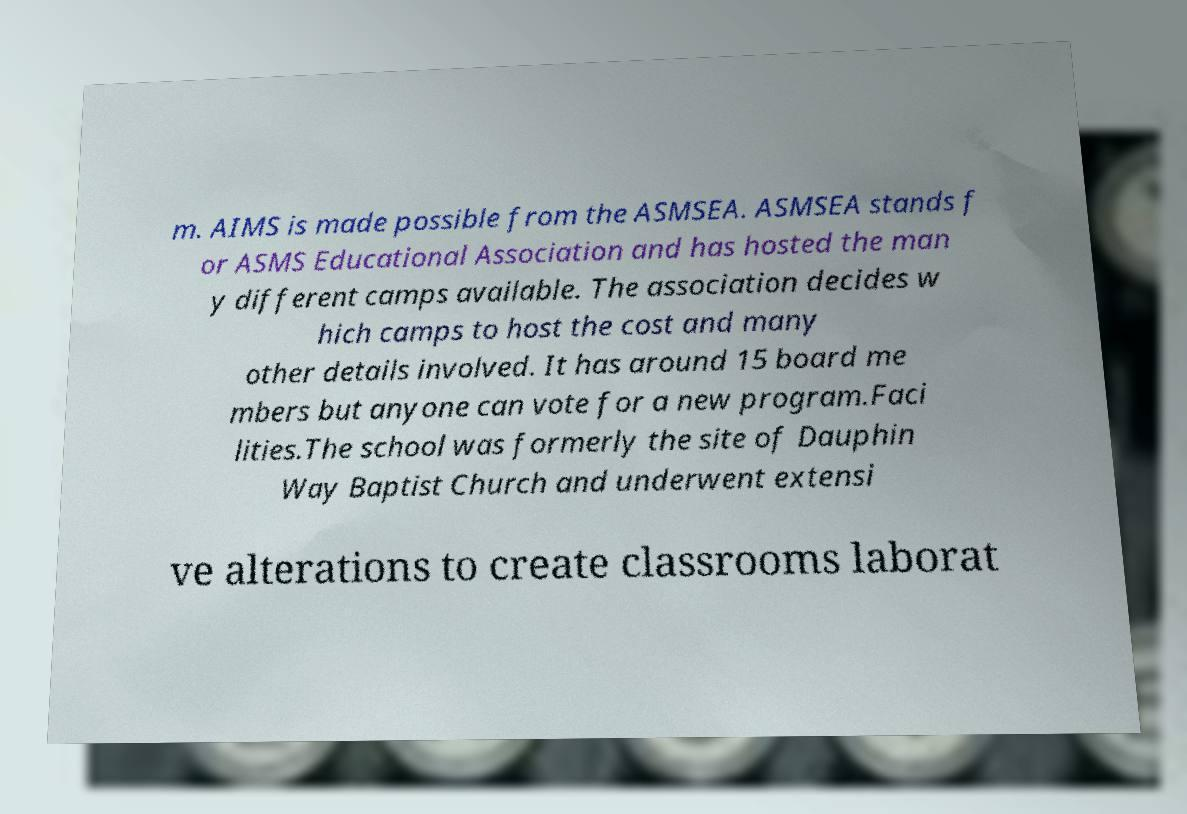Please read and relay the text visible in this image. What does it say? m. AIMS is made possible from the ASMSEA. ASMSEA stands f or ASMS Educational Association and has hosted the man y different camps available. The association decides w hich camps to host the cost and many other details involved. It has around 15 board me mbers but anyone can vote for a new program.Faci lities.The school was formerly the site of Dauphin Way Baptist Church and underwent extensi ve alterations to create classrooms laborat 